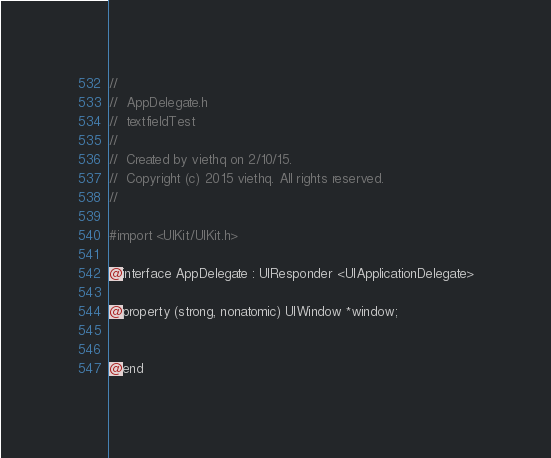<code> <loc_0><loc_0><loc_500><loc_500><_C_>//
//  AppDelegate.h
//  textfieldTest
//
//  Created by viethq on 2/10/15.
//  Copyright (c) 2015 viethq. All rights reserved.
//

#import <UIKit/UIKit.h>

@interface AppDelegate : UIResponder <UIApplicationDelegate>

@property (strong, nonatomic) UIWindow *window;


@end

</code> 